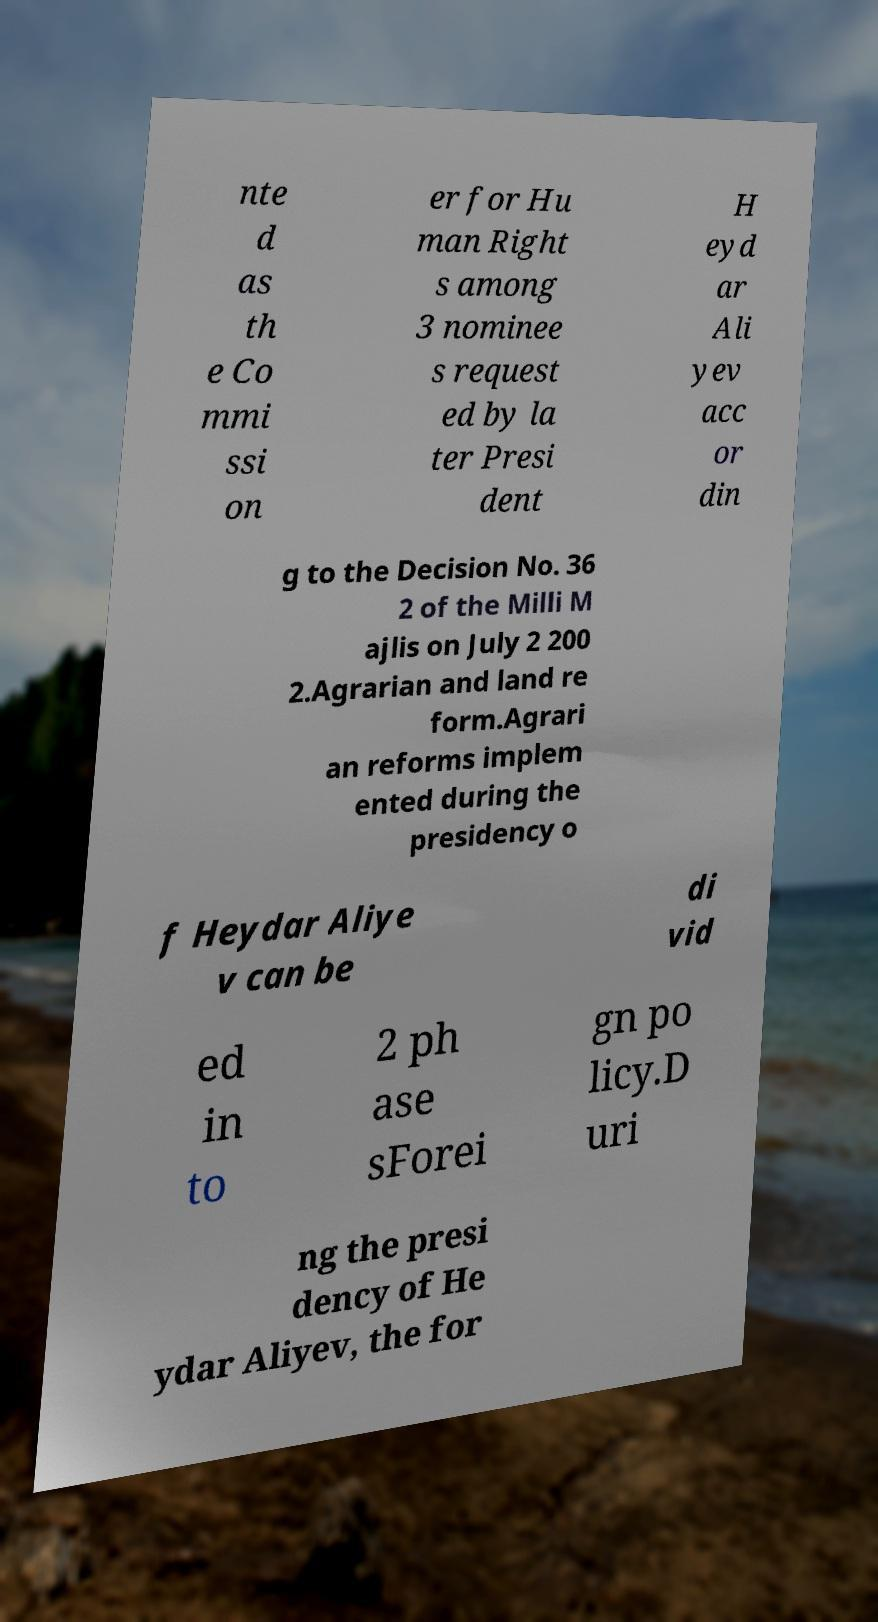Could you extract and type out the text from this image? nte d as th e Co mmi ssi on er for Hu man Right s among 3 nominee s request ed by la ter Presi dent H eyd ar Ali yev acc or din g to the Decision No. 36 2 of the Milli M ajlis on July 2 200 2.Agrarian and land re form.Agrari an reforms implem ented during the presidency o f Heydar Aliye v can be di vid ed in to 2 ph ase sForei gn po licy.D uri ng the presi dency of He ydar Aliyev, the for 